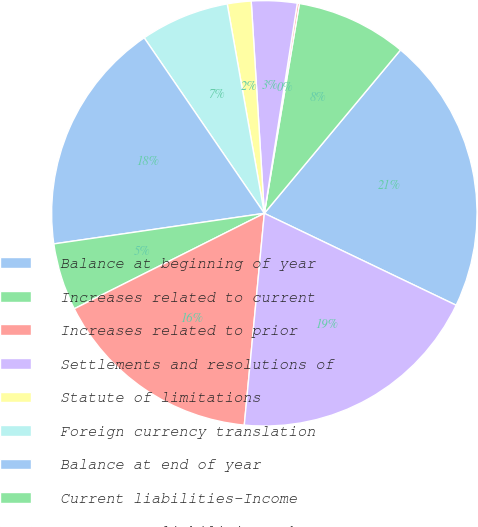<chart> <loc_0><loc_0><loc_500><loc_500><pie_chart><fcel>Balance at beginning of year<fcel>Increases related to current<fcel>Increases related to prior<fcel>Settlements and resolutions of<fcel>Statute of limitations<fcel>Foreign currency translation<fcel>Balance at end of year<fcel>Current liabilities-Income<fcel>Noncurrent liabilities-Other<fcel>Total<nl><fcel>21.05%<fcel>8.42%<fcel>0.16%<fcel>3.46%<fcel>1.81%<fcel>6.76%<fcel>17.74%<fcel>5.11%<fcel>16.09%<fcel>19.39%<nl></chart> 